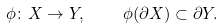Convert formula to latex. <formula><loc_0><loc_0><loc_500><loc_500>\phi \colon X \to Y , \quad \phi ( \partial X ) \subset \partial Y .</formula> 